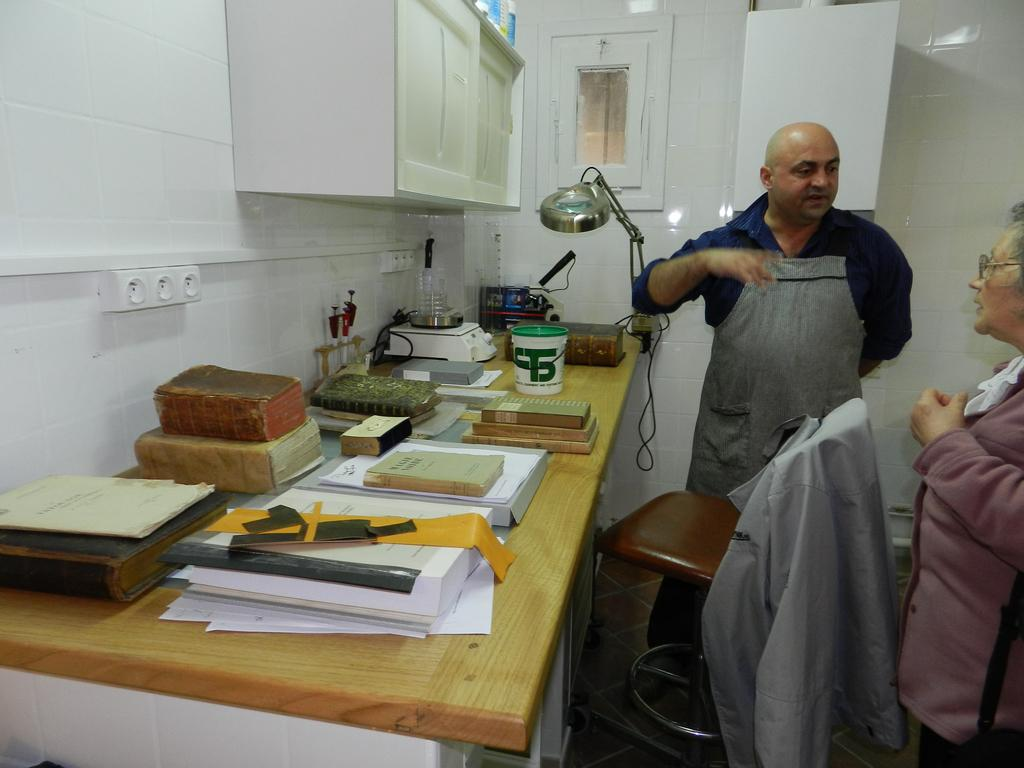What is the man doing in the image? The man is standing in the right side of the image and talking. What can be seen on the left side of the side of the image? There are books in the left side of the image. How many bulbs are present in the image? There is no mention of any bulbs in the image, so we cannot determine their presence or quantity. 